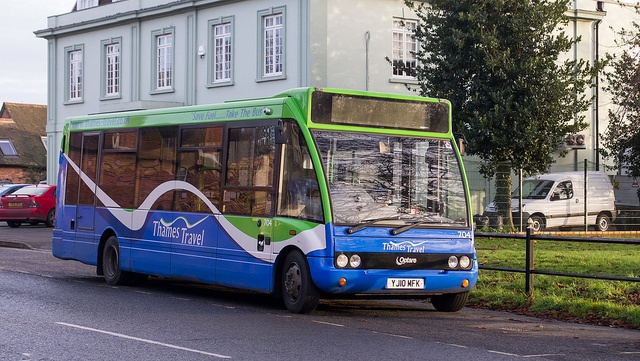Describe the objects in this image and their specific colors. I can see bus in white, black, gray, darkgray, and maroon tones, truck in white, lightgray, darkgray, black, and gray tones, car in white, purple, black, and brown tones, and car in white, lavender, gray, and darkgray tones in this image. 